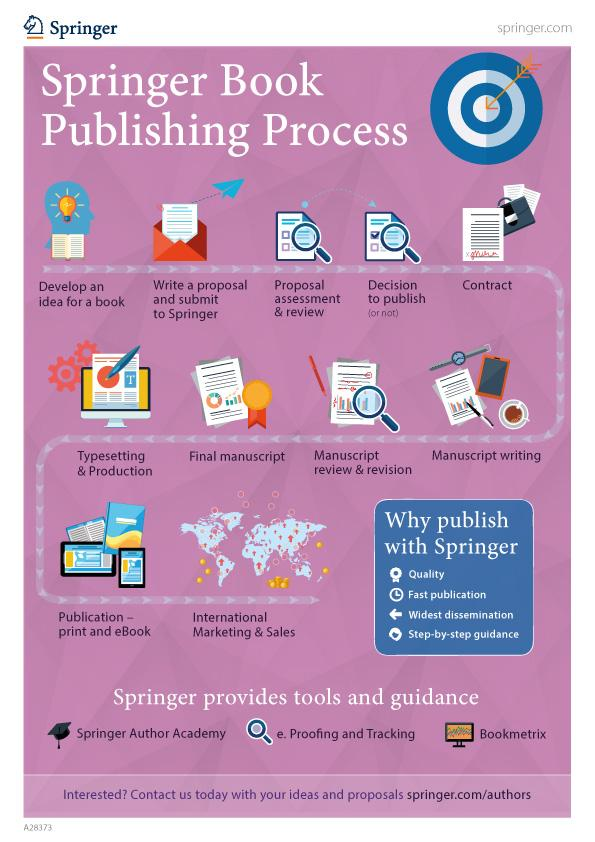Give some essential details in this illustration. The next step in the publishing process after developing an idea for a book is to write a proposal and submit it to Springer. After publishing a book, the next step in the publishing process is international marketing and sales. The next step in the publishing process after making the decision to publish a book is to contract. After finalizing the manuscript, the next step in the publishing process is typesetting and production. After writing a manuscript, it is necessary to undergo manuscript review and revision in order to ensure its accuracy and effectiveness. 